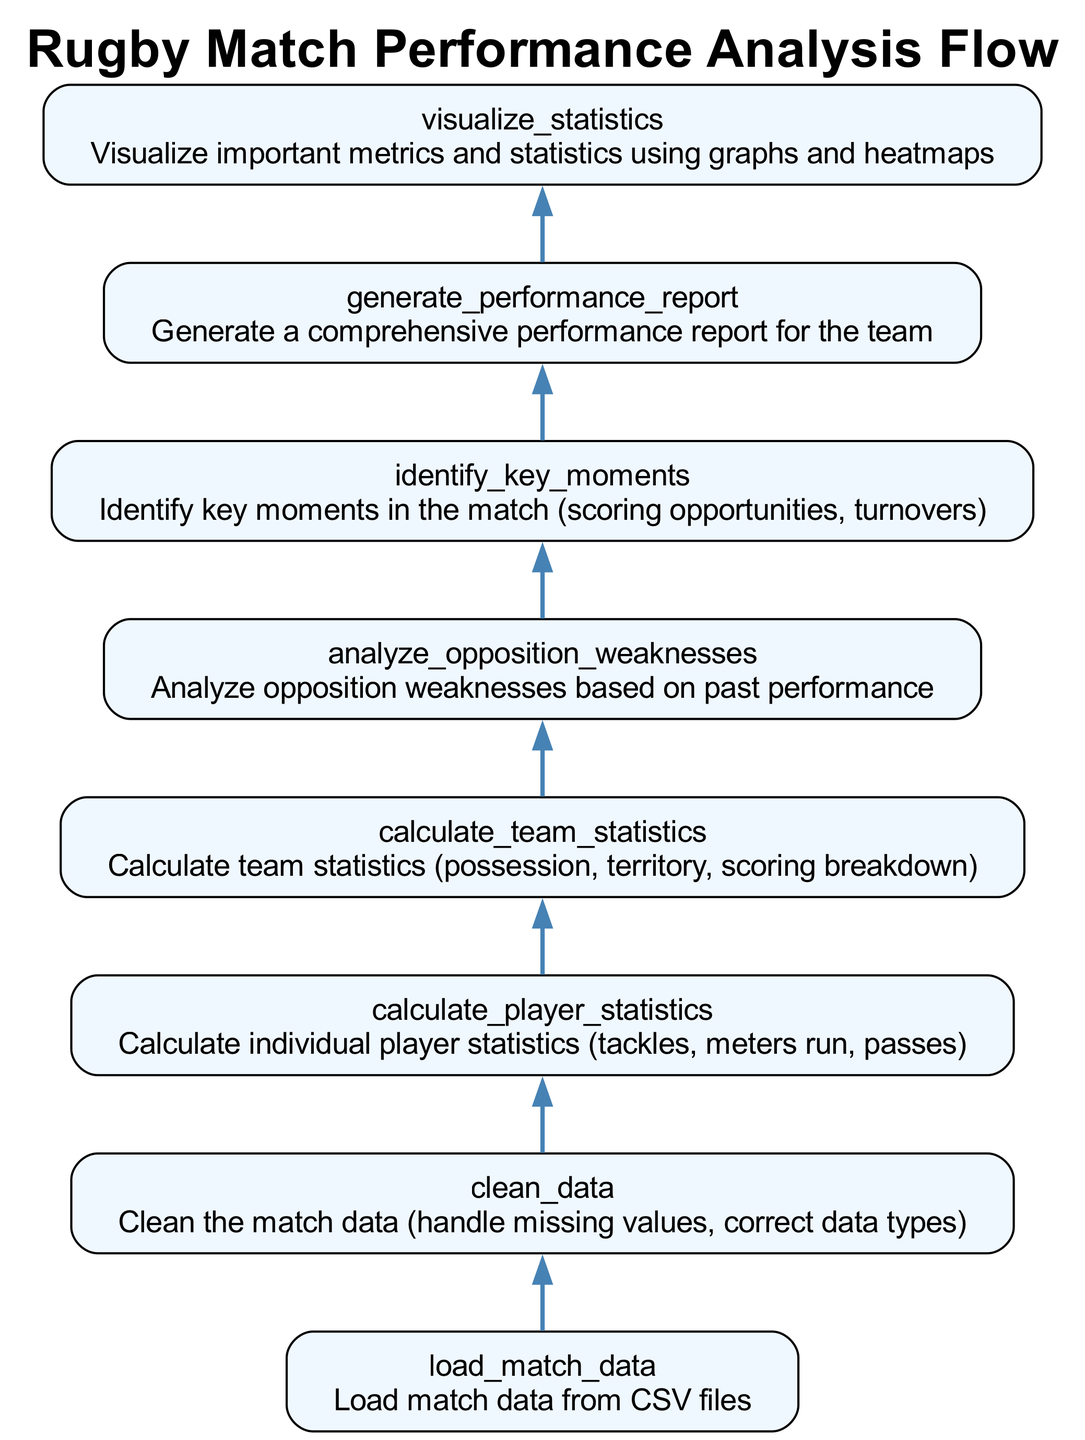What is the first step in the analysis flow? The first step in the flow is to load the match data from CSV files, which is indicated by the node "load_match_data".
Answer: load match data How many nodes are present in the diagram? Counting the nodes in the diagram, we have eight distinct elements that describe different steps in the analysis process, from loading data to generating a report.
Answer: 8 What follows after cleaning the data? Following the "clean_data" step, the next node processes individual player statistics, as shown in the diagram where it leads to "calculate_player_statistics".
Answer: calculate player statistics Which node focuses on visual representation? The node that is dedicated to visual representation of data is "visualize_statistics", which shows the step where important metrics are visualized using graphs and heatmaps.
Answer: visualize statistics Which two steps are related to performance evaluation? The steps related to performance evaluation are "analyze_opposition_weaknesses" and "generate_performance_report", as they both focus on evaluating aspects of the match performance.
Answer: analyze opposition weaknesses, generate performance report What node comes after identifying key moments? The node that follows "identify_key_moments" is "generate_performance_report", indicating that after identifying critical game moments, a report is generated.
Answer: generate performance report What is the last step in the flow chart? The last step in the flow chart is unmistakably "visualize_statistics", which concludes the analysis process by visualizing the collected insights.
Answer: visualize statistics What is the relationship between calculating player statistics and calculating team statistics? The relationship is that both of these nodes are essential for assessing individual and team performances concurrently; hence, they are sequential steps in the analysis.
Answer: sequential steps 